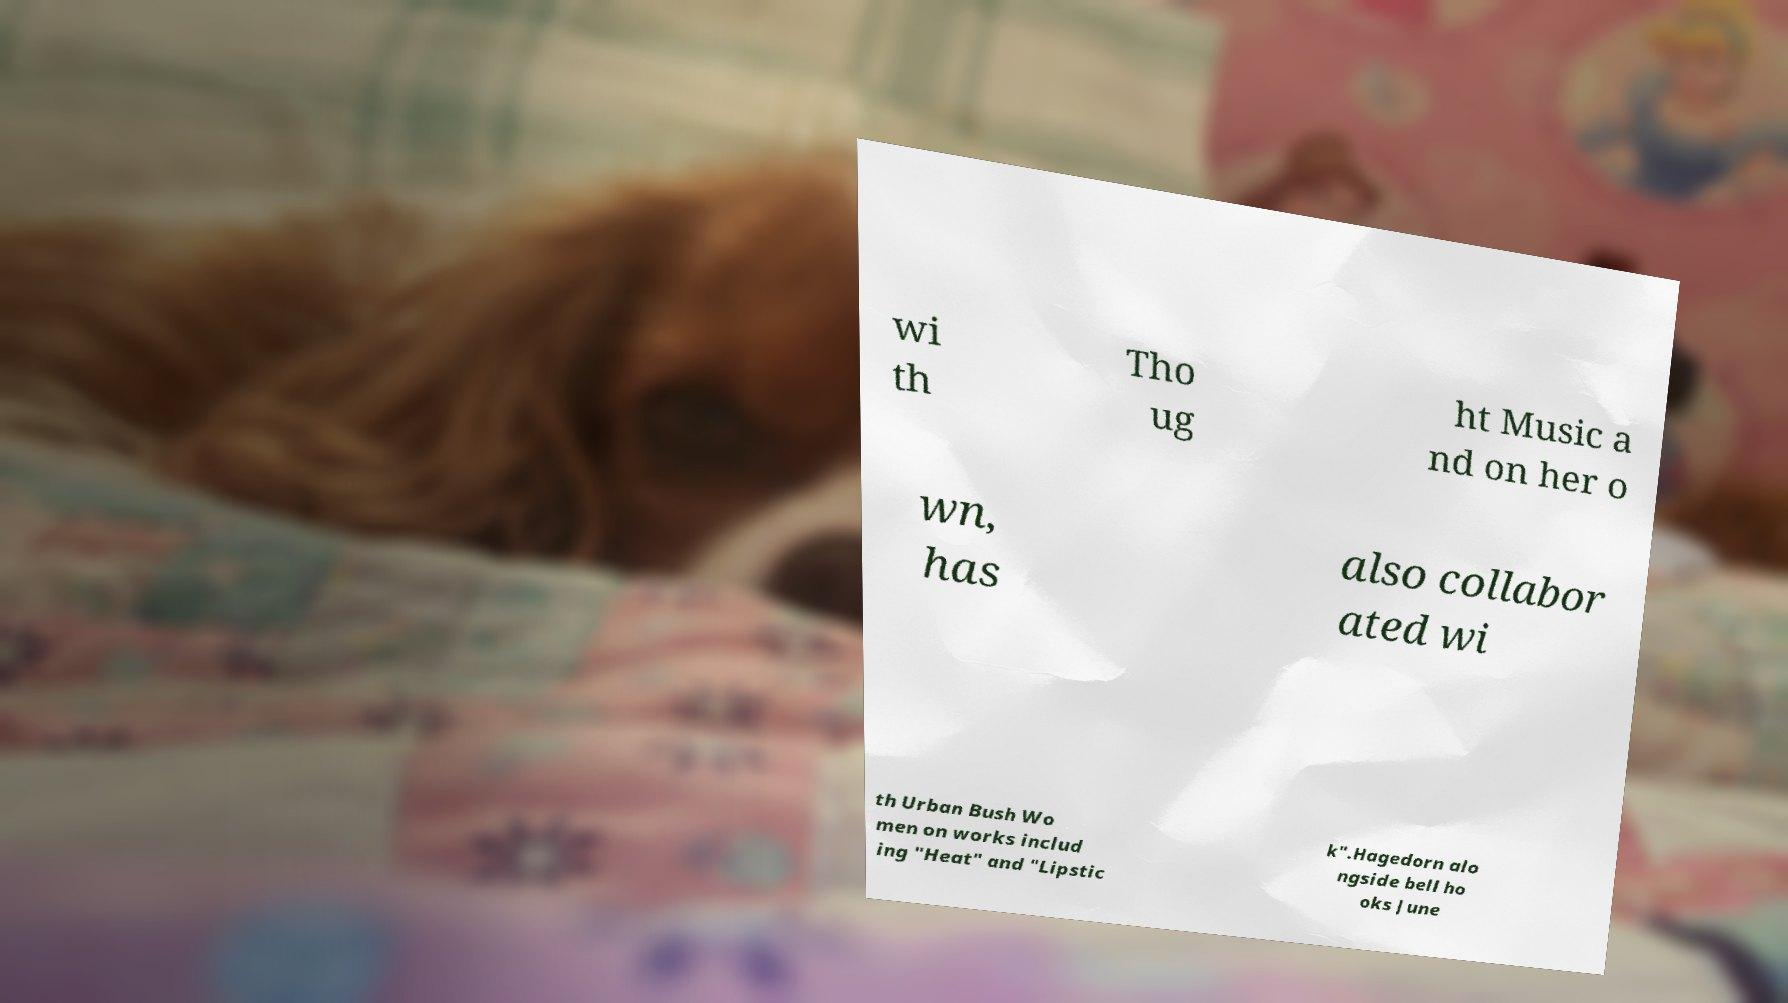I need the written content from this picture converted into text. Can you do that? wi th Tho ug ht Music a nd on her o wn, has also collabor ated wi th Urban Bush Wo men on works includ ing "Heat" and "Lipstic k".Hagedorn alo ngside bell ho oks June 